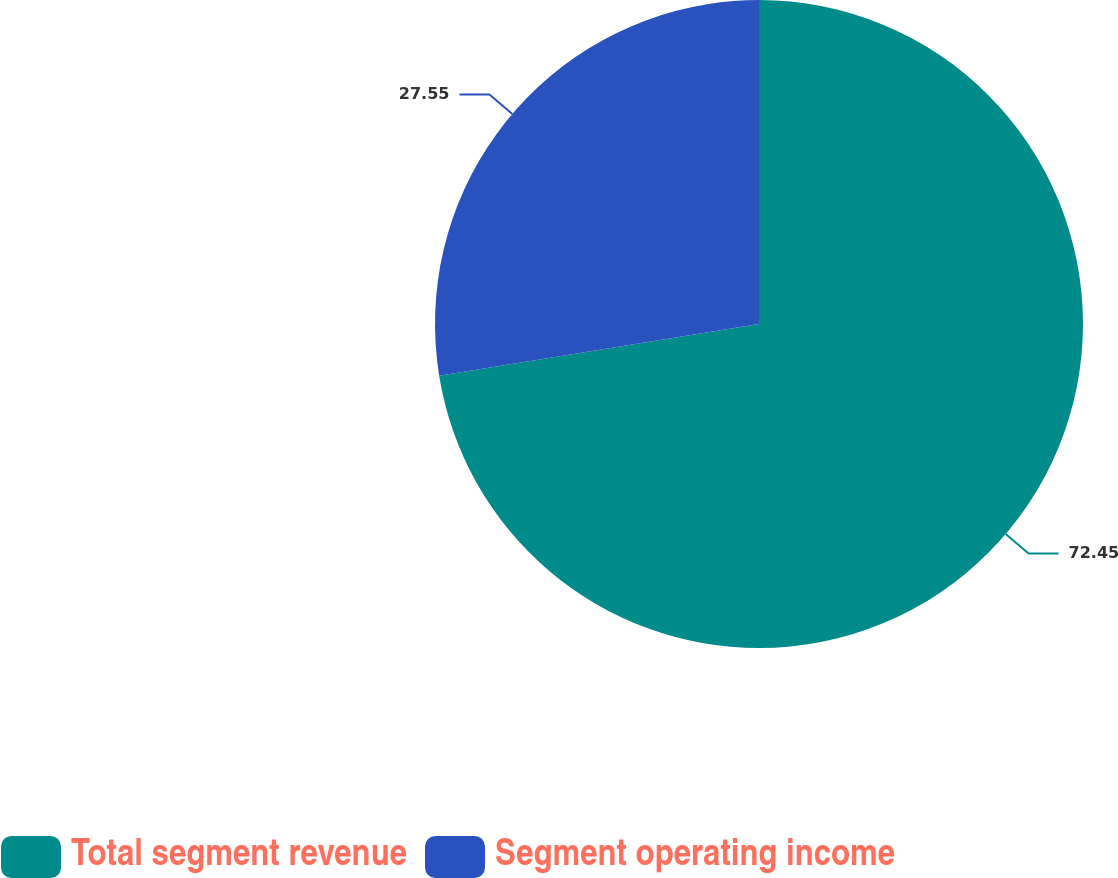Convert chart to OTSL. <chart><loc_0><loc_0><loc_500><loc_500><pie_chart><fcel>Total segment revenue<fcel>Segment operating income<nl><fcel>72.45%<fcel>27.55%<nl></chart> 